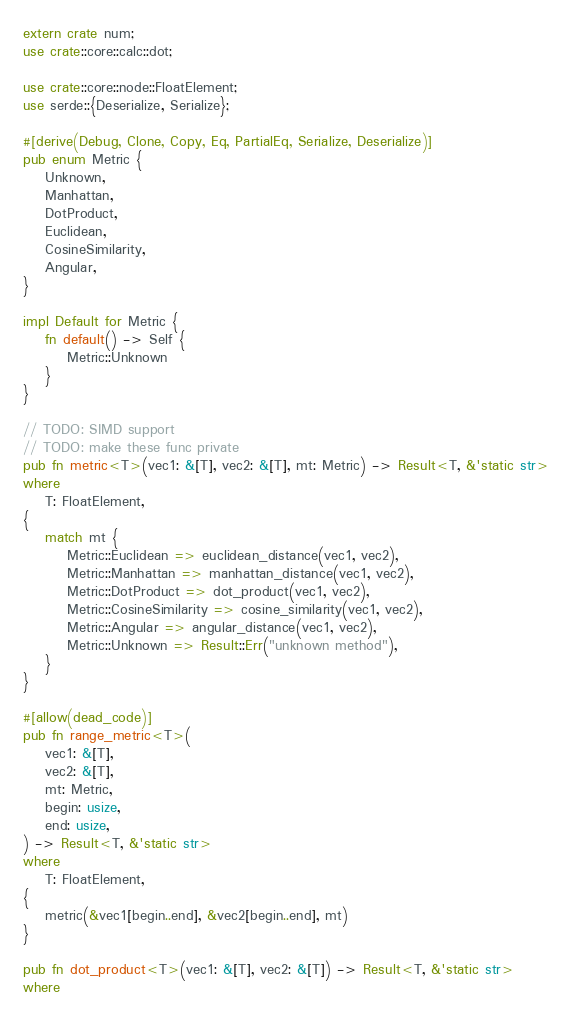<code> <loc_0><loc_0><loc_500><loc_500><_Rust_>extern crate num;
use crate::core::calc::dot;

use crate::core::node::FloatElement;
use serde::{Deserialize, Serialize};

#[derive(Debug, Clone, Copy, Eq, PartialEq, Serialize, Deserialize)]
pub enum Metric {
    Unknown,
    Manhattan,
    DotProduct,
    Euclidean,
    CosineSimilarity,
    Angular,
}

impl Default for Metric {
    fn default() -> Self {
        Metric::Unknown
    }
}

// TODO: SIMD support
// TODO: make these func private
pub fn metric<T>(vec1: &[T], vec2: &[T], mt: Metric) -> Result<T, &'static str>
where
    T: FloatElement,
{
    match mt {
        Metric::Euclidean => euclidean_distance(vec1, vec2),
        Metric::Manhattan => manhattan_distance(vec1, vec2),
        Metric::DotProduct => dot_product(vec1, vec2),
        Metric::CosineSimilarity => cosine_similarity(vec1, vec2),
        Metric::Angular => angular_distance(vec1, vec2),
        Metric::Unknown => Result::Err("unknown method"),
    }
}

#[allow(dead_code)]
pub fn range_metric<T>(
    vec1: &[T],
    vec2: &[T],
    mt: Metric,
    begin: usize,
    end: usize,
) -> Result<T, &'static str>
where
    T: FloatElement,
{
    metric(&vec1[begin..end], &vec2[begin..end], mt)
}

pub fn dot_product<T>(vec1: &[T], vec2: &[T]) -> Result<T, &'static str>
where</code> 